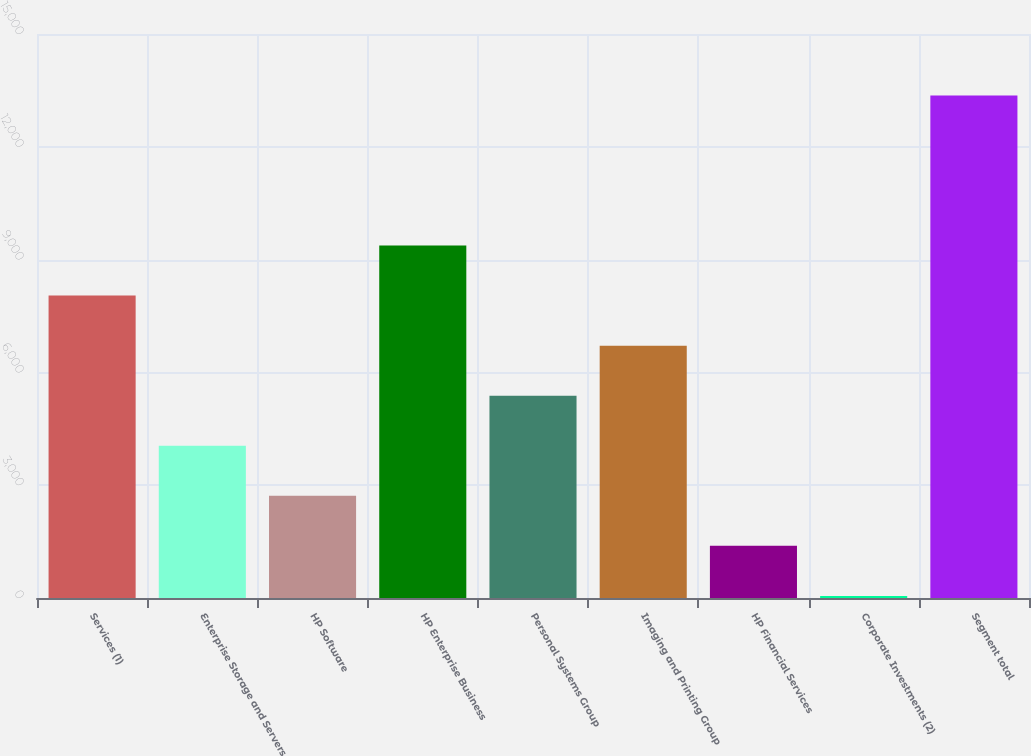Convert chart to OTSL. <chart><loc_0><loc_0><loc_500><loc_500><bar_chart><fcel>Services (1)<fcel>Enterprise Storage and Servers<fcel>HP Software<fcel>HP Enterprise Business<fcel>Personal Systems Group<fcel>Imaging and Printing Group<fcel>HP Financial Services<fcel>Corporate Investments (2)<fcel>Segment total<nl><fcel>8042.6<fcel>4049.3<fcel>2718.2<fcel>9373.7<fcel>5380.4<fcel>6711.5<fcel>1387.1<fcel>56<fcel>13367<nl></chart> 